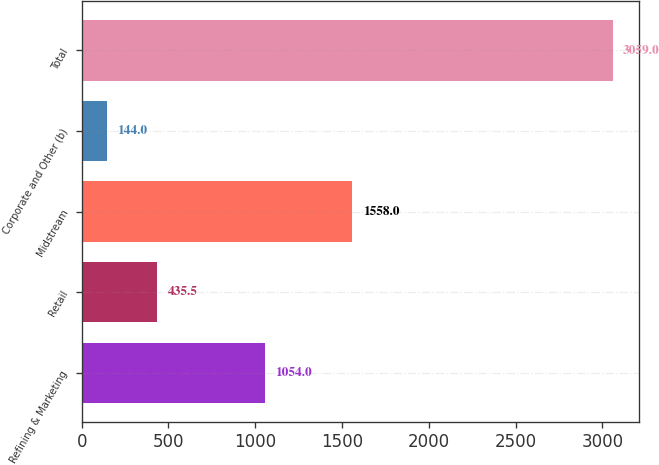Convert chart. <chart><loc_0><loc_0><loc_500><loc_500><bar_chart><fcel>Refining & Marketing<fcel>Retail<fcel>Midstream<fcel>Corporate and Other (b)<fcel>Total<nl><fcel>1054<fcel>435.5<fcel>1558<fcel>144<fcel>3059<nl></chart> 